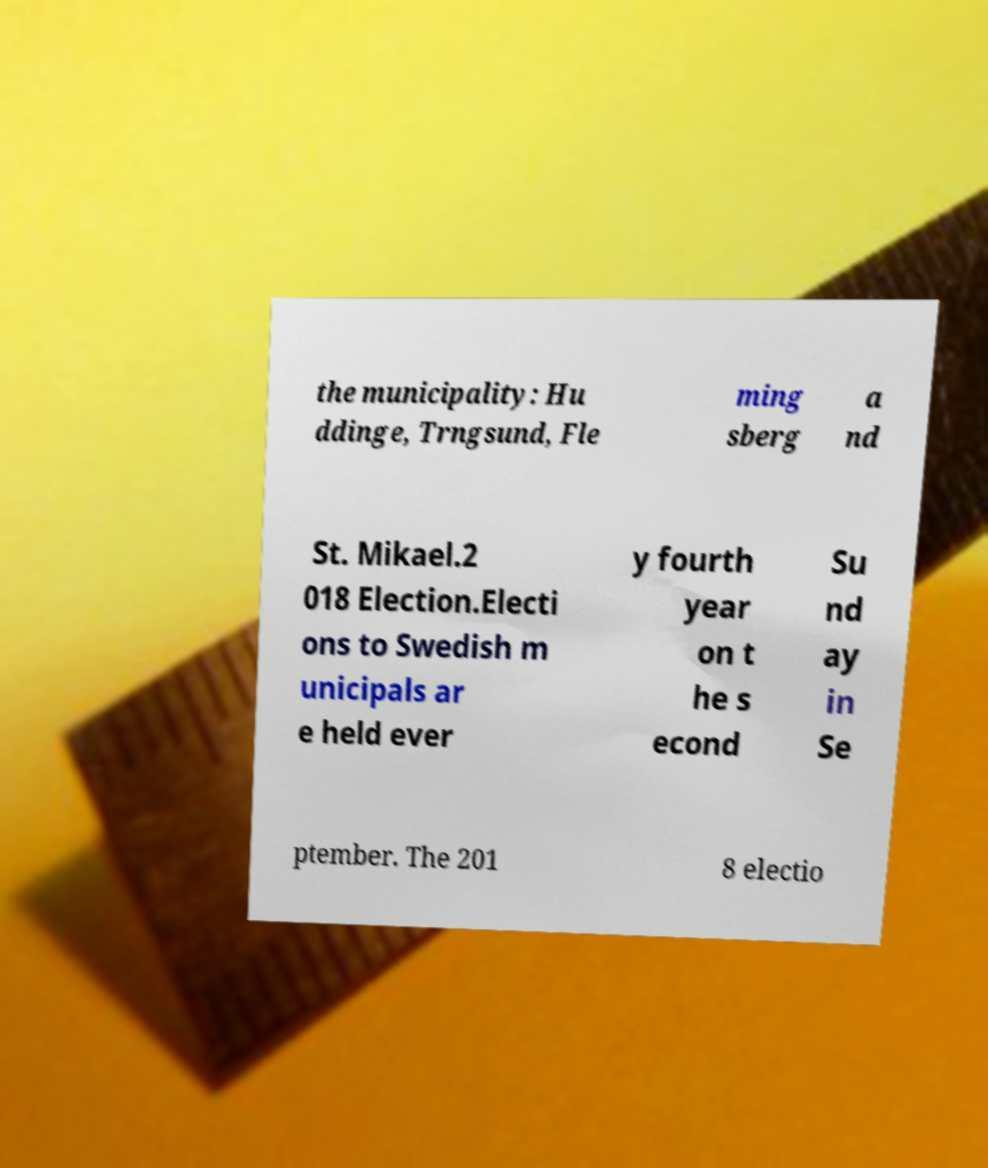Please identify and transcribe the text found in this image. the municipality: Hu ddinge, Trngsund, Fle ming sberg a nd St. Mikael.2 018 Election.Electi ons to Swedish m unicipals ar e held ever y fourth year on t he s econd Su nd ay in Se ptember. The 201 8 electio 